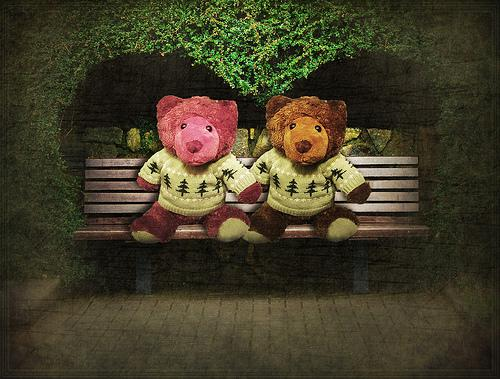Question: where are the bears sitting?
Choices:
A. In a cave.
B. Around the fire.
C. A bench.
D. In the house.
Answer with the letter. Answer: C Question: what clothes are the bears wearing?
Choices:
A. Hats.
B. Ties.
C. T-shirts.
D. Sweaters.
Answer with the letter. Answer: D Question: what plant is shown on the bear's sweaters?
Choices:
A. Aloe vera.
B. Sunflowers.
C. Trees.
D. Daisies.
Answer with the letter. Answer: C Question: how many eyes does each bear have?
Choices:
A. Three.
B. Four.
C. Two.
D. Five.
Answer with the letter. Answer: C 